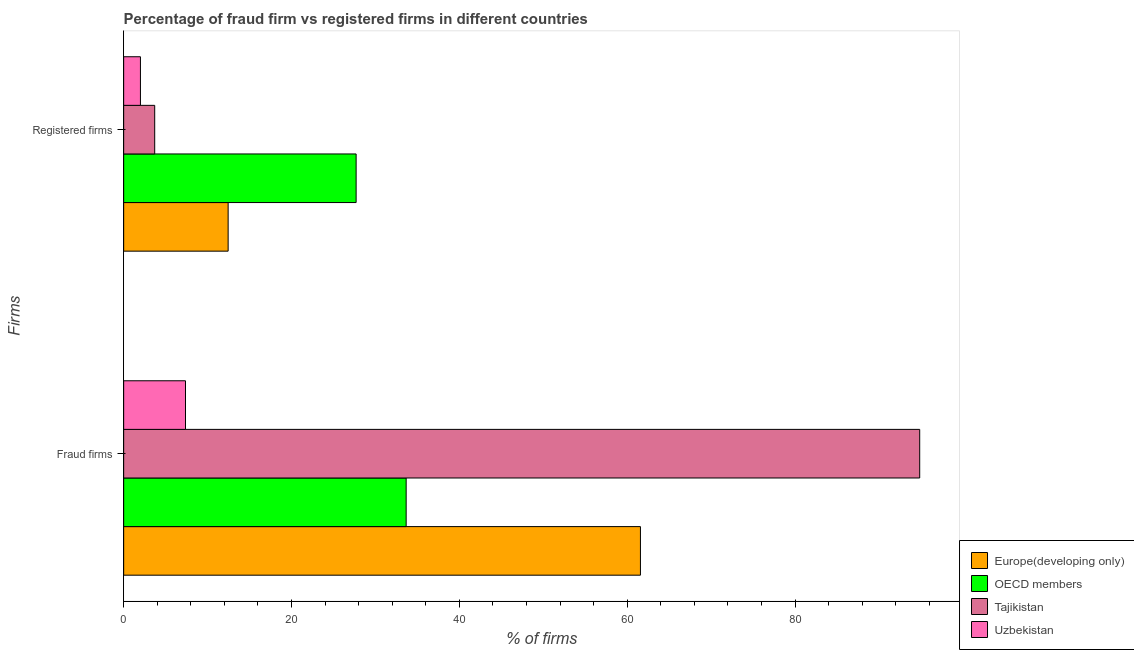Are the number of bars per tick equal to the number of legend labels?
Give a very brief answer. Yes. Are the number of bars on each tick of the Y-axis equal?
Your answer should be very brief. Yes. How many bars are there on the 1st tick from the top?
Your answer should be compact. 4. What is the label of the 1st group of bars from the top?
Ensure brevity in your answer.  Registered firms. Across all countries, what is the maximum percentage of fraud firms?
Ensure brevity in your answer.  94.85. Across all countries, what is the minimum percentage of registered firms?
Your response must be concise. 2. In which country was the percentage of registered firms minimum?
Ensure brevity in your answer.  Uzbekistan. What is the total percentage of fraud firms in the graph?
Offer a very short reply. 197.45. What is the difference between the percentage of registered firms in Tajikistan and that in OECD members?
Your answer should be compact. -24. What is the difference between the percentage of fraud firms in Tajikistan and the percentage of registered firms in Europe(developing only)?
Give a very brief answer. 82.4. What is the average percentage of fraud firms per country?
Your response must be concise. 49.36. What is the difference between the percentage of registered firms and percentage of fraud firms in Tajikistan?
Give a very brief answer. -91.15. In how many countries, is the percentage of registered firms greater than 72 %?
Your response must be concise. 0. What is the ratio of the percentage of fraud firms in Uzbekistan to that in Europe(developing only)?
Keep it short and to the point. 0.12. Is the percentage of fraud firms in Uzbekistan less than that in Europe(developing only)?
Your answer should be compact. Yes. How many bars are there?
Offer a very short reply. 8. Are all the bars in the graph horizontal?
Your answer should be compact. Yes. What is the difference between two consecutive major ticks on the X-axis?
Your answer should be compact. 20. Does the graph contain grids?
Keep it short and to the point. No. How many legend labels are there?
Give a very brief answer. 4. What is the title of the graph?
Your response must be concise. Percentage of fraud firm vs registered firms in different countries. Does "Channel Islands" appear as one of the legend labels in the graph?
Your answer should be compact. No. What is the label or title of the X-axis?
Keep it short and to the point. % of firms. What is the label or title of the Y-axis?
Offer a very short reply. Firms. What is the % of firms of Europe(developing only) in Fraud firms?
Give a very brief answer. 61.58. What is the % of firms in OECD members in Fraud firms?
Provide a succinct answer. 33.66. What is the % of firms of Tajikistan in Fraud firms?
Provide a short and direct response. 94.85. What is the % of firms of Uzbekistan in Fraud firms?
Your answer should be very brief. 7.37. What is the % of firms in Europe(developing only) in Registered firms?
Provide a short and direct response. 12.45. What is the % of firms of OECD members in Registered firms?
Your answer should be compact. 27.7. What is the % of firms in Uzbekistan in Registered firms?
Provide a succinct answer. 2. Across all Firms, what is the maximum % of firms of Europe(developing only)?
Provide a short and direct response. 61.58. Across all Firms, what is the maximum % of firms in OECD members?
Provide a succinct answer. 33.66. Across all Firms, what is the maximum % of firms in Tajikistan?
Provide a short and direct response. 94.85. Across all Firms, what is the maximum % of firms of Uzbekistan?
Your response must be concise. 7.37. Across all Firms, what is the minimum % of firms of Europe(developing only)?
Ensure brevity in your answer.  12.45. Across all Firms, what is the minimum % of firms of OECD members?
Provide a succinct answer. 27.7. Across all Firms, what is the minimum % of firms in Uzbekistan?
Give a very brief answer. 2. What is the total % of firms in Europe(developing only) in the graph?
Provide a succinct answer. 74.03. What is the total % of firms in OECD members in the graph?
Give a very brief answer. 61.36. What is the total % of firms in Tajikistan in the graph?
Keep it short and to the point. 98.55. What is the total % of firms of Uzbekistan in the graph?
Provide a succinct answer. 9.37. What is the difference between the % of firms in Europe(developing only) in Fraud firms and that in Registered firms?
Provide a short and direct response. 49.12. What is the difference between the % of firms in OECD members in Fraud firms and that in Registered firms?
Your response must be concise. 5.96. What is the difference between the % of firms in Tajikistan in Fraud firms and that in Registered firms?
Keep it short and to the point. 91.15. What is the difference between the % of firms in Uzbekistan in Fraud firms and that in Registered firms?
Provide a short and direct response. 5.37. What is the difference between the % of firms in Europe(developing only) in Fraud firms and the % of firms in OECD members in Registered firms?
Provide a succinct answer. 33.88. What is the difference between the % of firms in Europe(developing only) in Fraud firms and the % of firms in Tajikistan in Registered firms?
Provide a succinct answer. 57.88. What is the difference between the % of firms in Europe(developing only) in Fraud firms and the % of firms in Uzbekistan in Registered firms?
Offer a very short reply. 59.58. What is the difference between the % of firms of OECD members in Fraud firms and the % of firms of Tajikistan in Registered firms?
Give a very brief answer. 29.96. What is the difference between the % of firms in OECD members in Fraud firms and the % of firms in Uzbekistan in Registered firms?
Your answer should be very brief. 31.66. What is the difference between the % of firms of Tajikistan in Fraud firms and the % of firms of Uzbekistan in Registered firms?
Make the answer very short. 92.85. What is the average % of firms in Europe(developing only) per Firms?
Keep it short and to the point. 37.01. What is the average % of firms in OECD members per Firms?
Offer a very short reply. 30.68. What is the average % of firms of Tajikistan per Firms?
Provide a short and direct response. 49.27. What is the average % of firms of Uzbekistan per Firms?
Offer a terse response. 4.68. What is the difference between the % of firms in Europe(developing only) and % of firms in OECD members in Fraud firms?
Give a very brief answer. 27.91. What is the difference between the % of firms of Europe(developing only) and % of firms of Tajikistan in Fraud firms?
Your answer should be compact. -33.27. What is the difference between the % of firms of Europe(developing only) and % of firms of Uzbekistan in Fraud firms?
Provide a succinct answer. 54.2. What is the difference between the % of firms in OECD members and % of firms in Tajikistan in Fraud firms?
Provide a succinct answer. -61.19. What is the difference between the % of firms in OECD members and % of firms in Uzbekistan in Fraud firms?
Ensure brevity in your answer.  26.29. What is the difference between the % of firms in Tajikistan and % of firms in Uzbekistan in Fraud firms?
Provide a succinct answer. 87.48. What is the difference between the % of firms of Europe(developing only) and % of firms of OECD members in Registered firms?
Your response must be concise. -15.25. What is the difference between the % of firms of Europe(developing only) and % of firms of Tajikistan in Registered firms?
Provide a succinct answer. 8.75. What is the difference between the % of firms of Europe(developing only) and % of firms of Uzbekistan in Registered firms?
Provide a short and direct response. 10.45. What is the difference between the % of firms of OECD members and % of firms of Uzbekistan in Registered firms?
Offer a very short reply. 25.7. What is the difference between the % of firms of Tajikistan and % of firms of Uzbekistan in Registered firms?
Provide a succinct answer. 1.7. What is the ratio of the % of firms in Europe(developing only) in Fraud firms to that in Registered firms?
Give a very brief answer. 4.95. What is the ratio of the % of firms of OECD members in Fraud firms to that in Registered firms?
Your answer should be very brief. 1.22. What is the ratio of the % of firms of Tajikistan in Fraud firms to that in Registered firms?
Offer a very short reply. 25.64. What is the ratio of the % of firms of Uzbekistan in Fraud firms to that in Registered firms?
Your response must be concise. 3.69. What is the difference between the highest and the second highest % of firms of Europe(developing only)?
Ensure brevity in your answer.  49.12. What is the difference between the highest and the second highest % of firms in OECD members?
Provide a short and direct response. 5.96. What is the difference between the highest and the second highest % of firms of Tajikistan?
Offer a terse response. 91.15. What is the difference between the highest and the second highest % of firms of Uzbekistan?
Provide a short and direct response. 5.37. What is the difference between the highest and the lowest % of firms of Europe(developing only)?
Offer a very short reply. 49.12. What is the difference between the highest and the lowest % of firms in OECD members?
Offer a terse response. 5.96. What is the difference between the highest and the lowest % of firms of Tajikistan?
Your answer should be compact. 91.15. What is the difference between the highest and the lowest % of firms of Uzbekistan?
Ensure brevity in your answer.  5.37. 